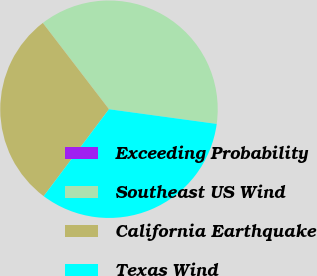Convert chart to OTSL. <chart><loc_0><loc_0><loc_500><loc_500><pie_chart><fcel>Exceeding Probability<fcel>Southeast US Wind<fcel>California Earthquake<fcel>Texas Wind<nl><fcel>0.01%<fcel>37.56%<fcel>29.34%<fcel>33.09%<nl></chart> 